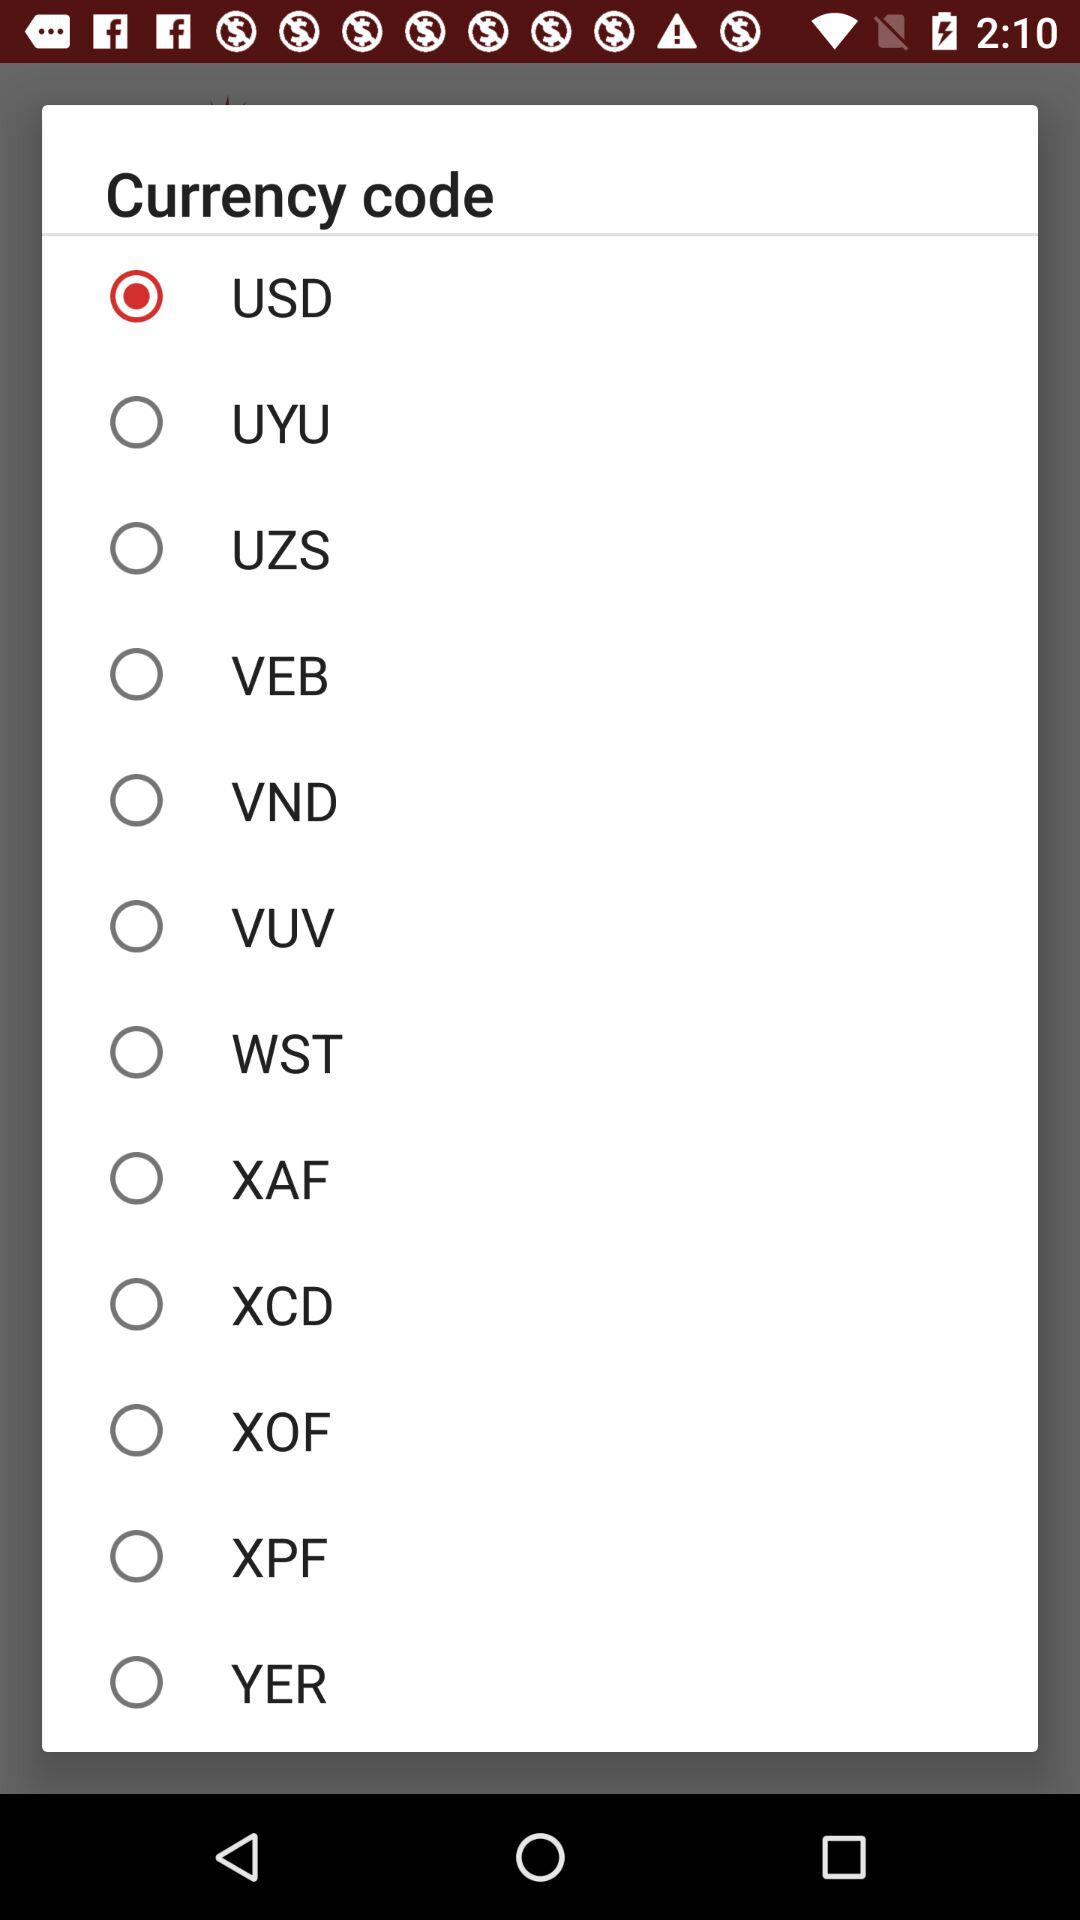Which option is selected as a currency code? The selected option is "USD". 